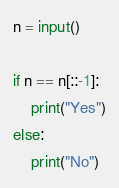<code> <loc_0><loc_0><loc_500><loc_500><_Python_>n = input()

if n == n[::-1]:
    print("Yes")
else:
    print("No")</code> 